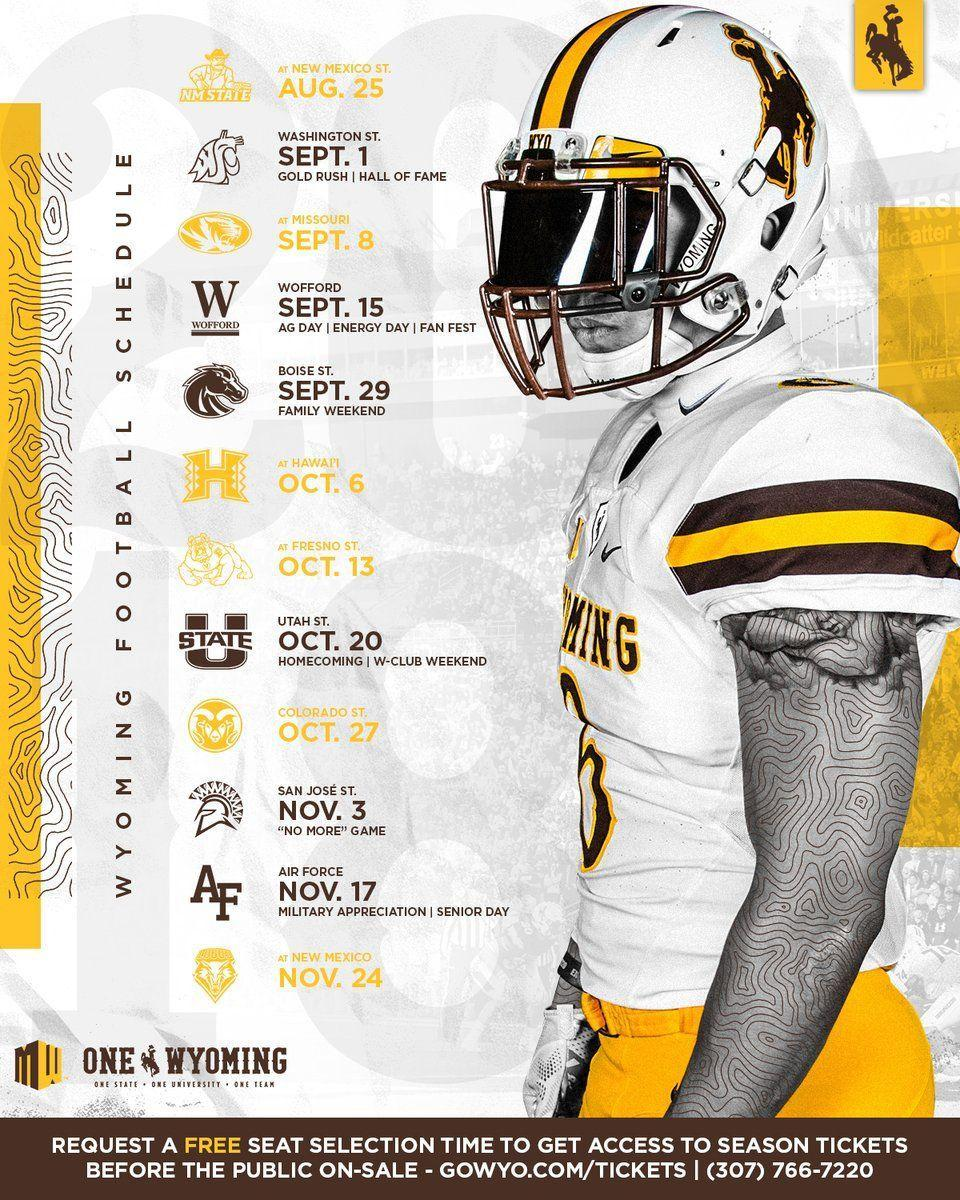what schedule has been shared
Answer the question with a short phrase. wyoming football schedule When is senior day Nov. 17 what is the alphabet in the logo of Wofford W what is the colour of the logo for Hawaii , yellow or white yellow Which alphabets are shown in the logo of Air Force AF 